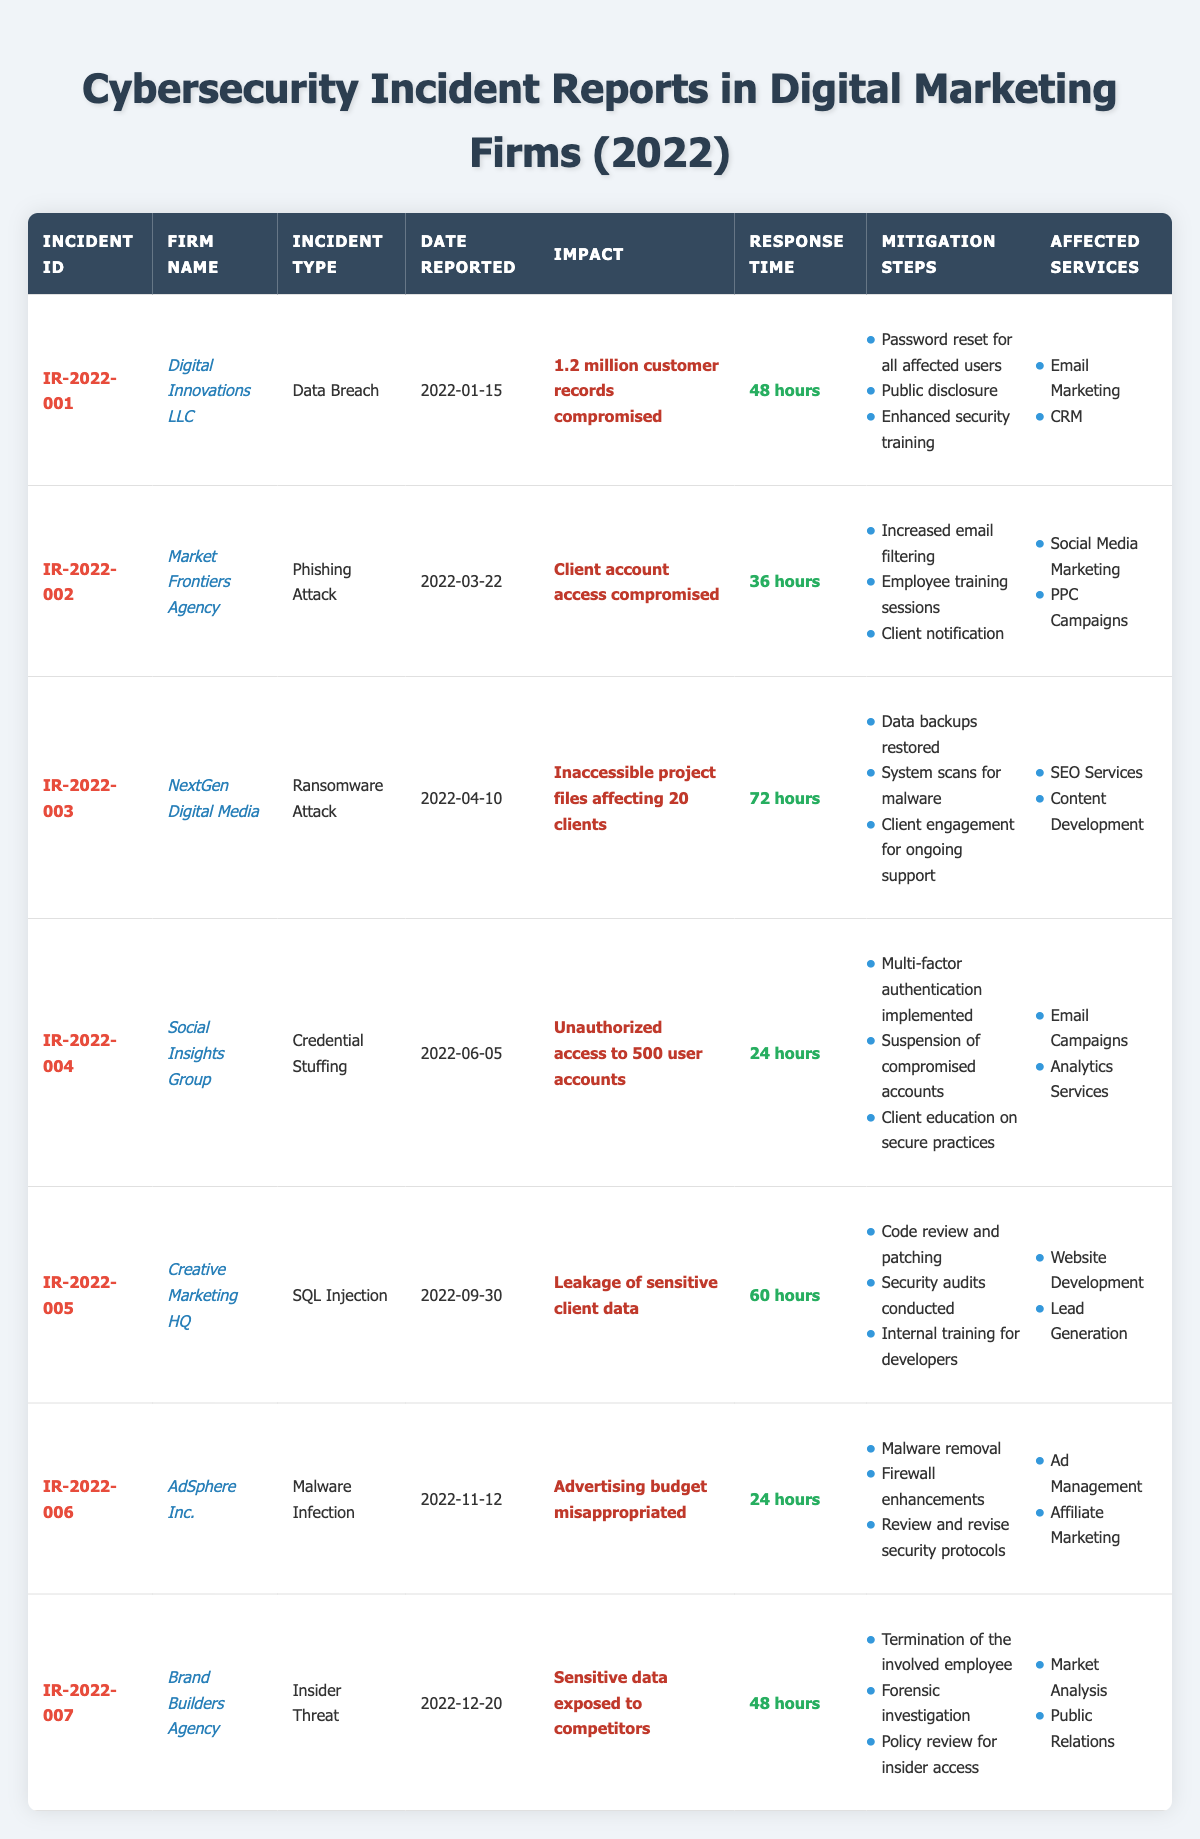What is the incident type reported by Digital Innovations LLC? The table provides the incident types for each firm. By locating the row for Digital Innovations LLC, I find that the incident type is "Data Breach."
Answer: Data Breach How many customer records were compromised in the incident reported by Digital Innovations LLC? The "impact" column provides details about the incidents. For Digital Innovations LLC, it states "1.2 million customer records compromised."
Answer: 1.2 million Which firm reported a ransomware attack, and what was the impact? By scanning the table for the incident type "Ransomware Attack," I locate the entry for NextGen Digital Media, whose impact states "Inaccessible project files affecting 20 clients."
Answer: NextGen Digital Media; Inaccessible project files affecting 20 clients Which incident had the shortest response time, and how long was it? To answer this, I need to compare response times across all incidents. The shortest response time listed is "24 hours" for two incidents: Social Insights Group and AdSphere Inc.
Answer: Social Insights Group and AdSphere Inc.; 24 hours Was any sensitive data exposed as a result of the insider threat reported by Brand Builders Agency? Looking at the impact column for Brand Builders Agency, it states "Sensitive data exposed to competitors," confirming that sensitive data was indeed exposed.
Answer: Yes How many firms experienced data breaches in 2022? By reviewing the table, I count the number of rows classified as "Data Breach." There is only one firm, Digital Innovations LLC, reported under this incident type.
Answer: 1 What is the average response time for all incidents reported? I calculate the average by converting the response times into numeric values: 48, 36, 72, 24, 60, 24, and 48 hours. The sum is 312 hours, and there are 7 incidents. The average response time is 312/7 = 44.57 hours.
Answer: 44.57 hours Which mitigation step was taken for the phishing attack reported by Market Frontiers Agency? In the row for Market Frontiers Agency, under mitigation steps, the listed actions include "Increased email filtering," "Employee training sessions," and "Client notification."
Answer: Increased email filtering Did any incidents lead to unauthorized access to user accounts? Checking the impact descriptions, the entry for Social Insights Group indicates "Unauthorized access to 500 user accounts," confirming that this incident did indeed lead to unauthorized access.
Answer: Yes 